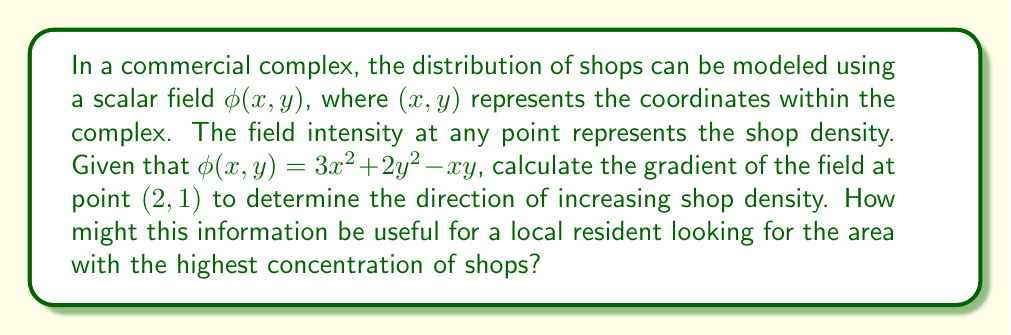Show me your answer to this math problem. To solve this problem, we'll follow these steps:

1) The gradient of a scalar field $\phi(x,y)$ is given by:

   $$\nabla \phi = \left(\frac{\partial \phi}{\partial x}, \frac{\partial \phi}{\partial y}\right)$$

2) Let's calculate the partial derivatives:

   $$\frac{\partial \phi}{\partial x} = 6x - y$$
   $$\frac{\partial \phi}{\partial y} = 4y - x$$

3) Now, we can write the gradient as:

   $$\nabla \phi = (6x - y, 4y - x)$$

4) We need to evaluate this at the point $(2,1)$:

   $$\nabla \phi(2,1) = (6(2) - 1, 4(1) - 2)$$
   $$\nabla \phi(2,1) = (11, 2)$$

5) This vector $(11,2)$ points in the direction of steepest increase in shop density from the point $(2,1)$.

6) For a local resident, this information indicates that moving in the direction of this vector from the point $(2,1)$ will lead to areas with a higher concentration of shops. The magnitude of the vector, $\sqrt{11^2 + 2^2} \approx 11.18$, indicates how rapidly the shop density is increasing in this direction.
Answer: $\nabla \phi(2,1) = (11, 2)$ 